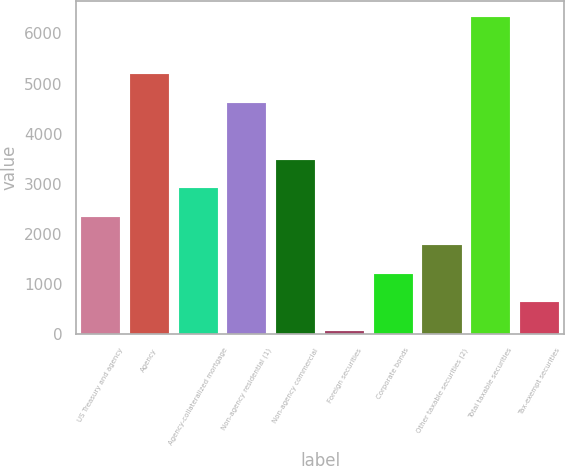<chart> <loc_0><loc_0><loc_500><loc_500><bar_chart><fcel>US Treasury and agency<fcel>Agency<fcel>Agency-collateralized mortgage<fcel>Non-agency residential (1)<fcel>Non-agency commercial<fcel>Foreign securities<fcel>Corporate bonds<fcel>Other taxable securities (2)<fcel>Total taxable securities<fcel>Tax-exempt securities<nl><fcel>2339.8<fcel>5188.3<fcel>2909.5<fcel>4618.6<fcel>3479.2<fcel>61<fcel>1200.4<fcel>1770.1<fcel>6327.7<fcel>630.7<nl></chart> 